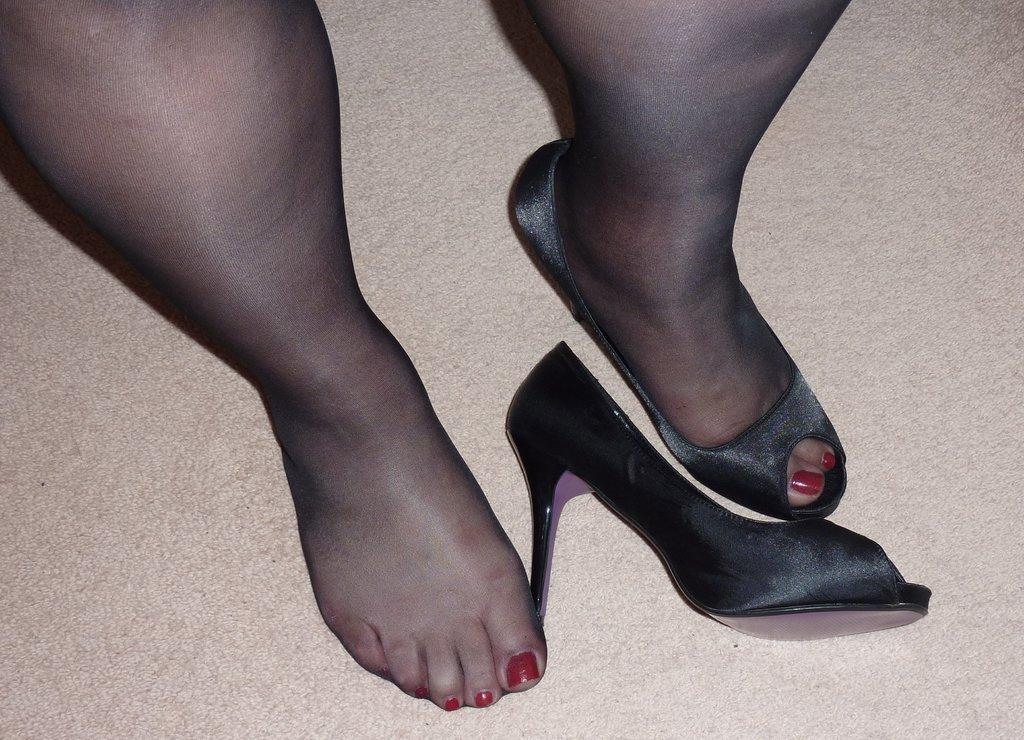What is the main subject of the image? The main subject of the image is a person's legs and sand heels. What type of footwear is the person wearing? The person is wearing sand heels. What can be seen in the background of the image? The background of the image includes a floor. Can you tell me how many airports are visible in the image? There are no airports visible in the image; it only features a person's legs and sand heels against a floor background. 